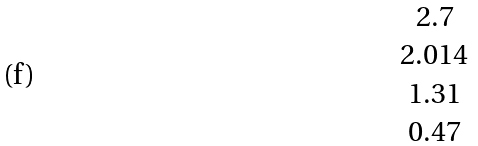<formula> <loc_0><loc_0><loc_500><loc_500>\begin{matrix} 2 . 7 \\ 2 . 0 1 4 \\ 1 . 3 1 \\ 0 . 4 7 \end{matrix}</formula> 